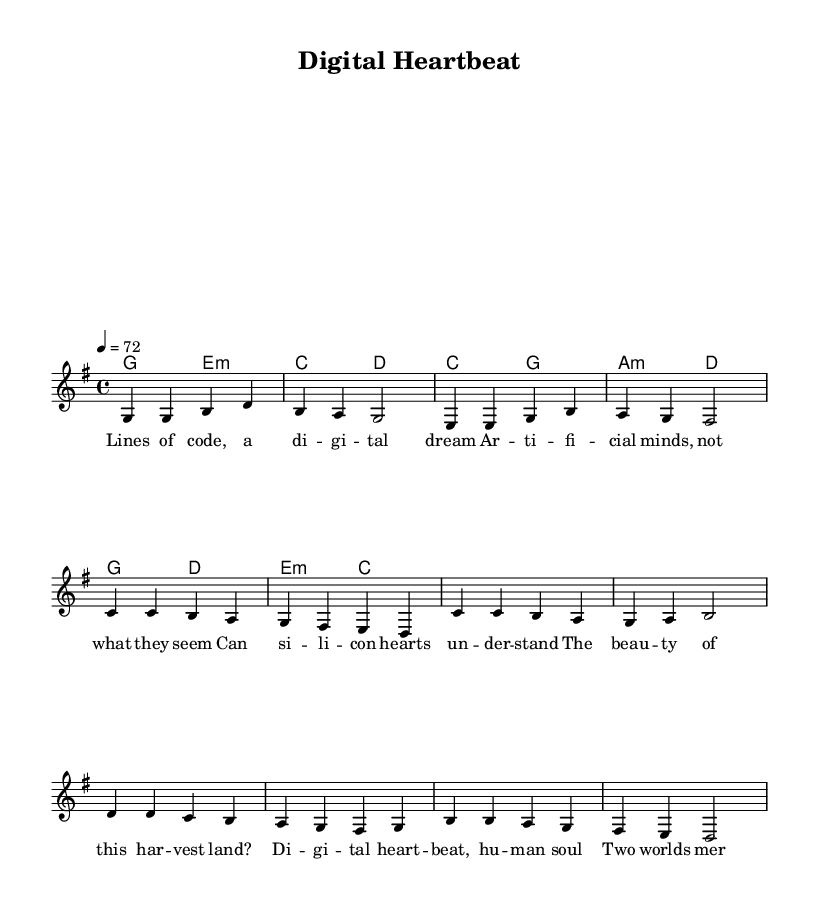What is the key signature of this music? The key signature is G major, which has one sharp (F#). We determine this by observing the key signature symbol located at the beginning of the staff.
Answer: G major What is the time signature of this music? The time signature is 4/4, indicated by the fraction at the beginning of the score. This means there are four beats in each measure and the quarter note gets one beat.
Answer: 4/4 What is the tempo marking for this music? The tempo marking is 72 beats per minute, indicated by the phrase "4 = 72" at the beginning of the score, which specifies the number of beats in a minute.
Answer: 72 How many measures are there in the verse section? The verse section contains eight measures, which can be counted by identifying the bar lines separating groups of music notation in the section labeled "Verse."
Answer: 8 What chord follows the G major chord in the verse? The chord that follows the G major chord is E minor, which is indicated in the harmony section. Each chord is listed sequentially, showing the progression used in the verse.
Answer: E minor What lyrical theme is explored in this music? The lyrical theme centers around the intersection of technology and humanity, as indicated by phrases like "digital heart" and "artificial minds" in the lyrics, reflecting concerns and reflections about artificial intelligence.
Answer: Technology and humanity Which section contains the highest pitch note? The highest pitch note appears in the pre-chorus section, specifically in the note C, which is indicated as C' in the melody line, showing that it is the highest note on the staff.
Answer: C 